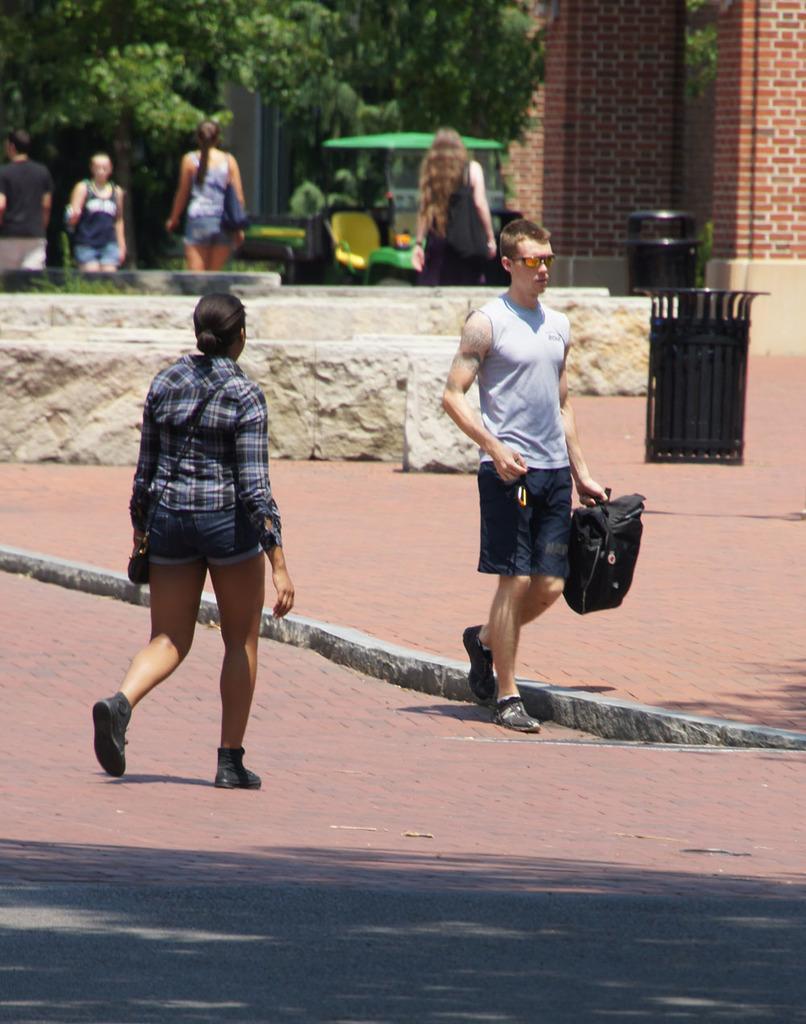In one or two sentences, can you explain what this image depicts? This is the picture outside the city,here we can see a person and a woman walking opposite to each other,here we can also see some trees which are away from the man and woman,here we can also see some people walking,here we can also see the wall with red bricks,here we can see that a man holding a bag.. 